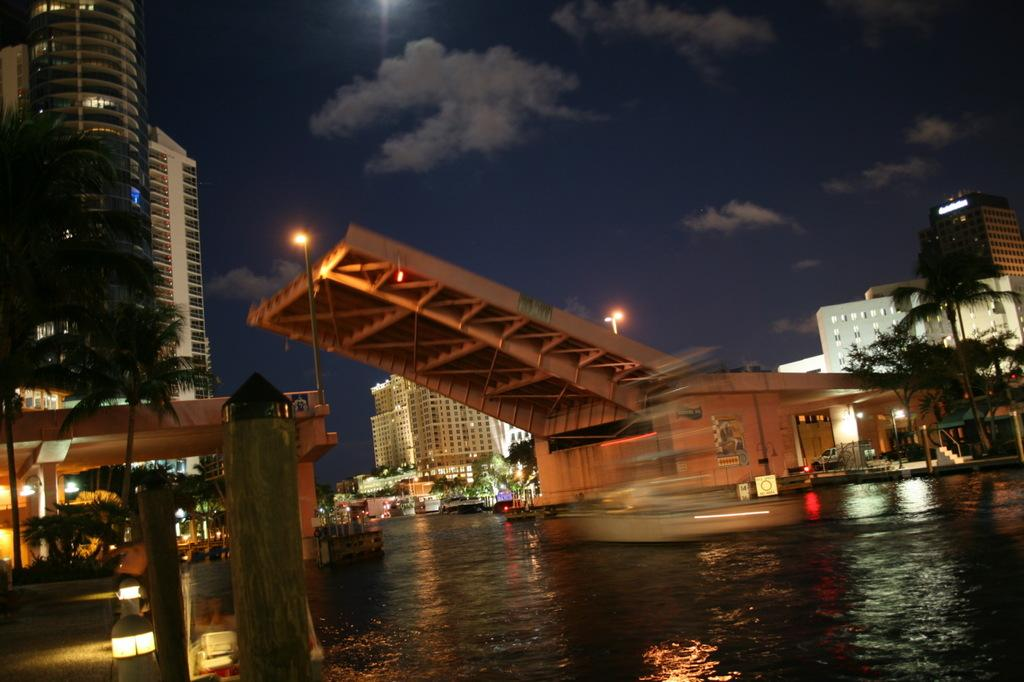What is present in the image that represents a body of water? There is water in the image. What structure can be seen crossing over the water? There is a bridge in the image. What type of man-made structures are visible in the image? There are buildings in the image. What type of vegetation can be seen in the image? There are trees in the image. What type of illumination is present in the image? There are lights in the image. What can be observed about the sky in the background of the image? The sky in the background is dark. What nation is represented by the flags in the image? There are no flags present in the image, so it is not possible to determine which nation is represented. How many men are visible in the image? There are no men visible in the image; the focus is on the water, bridge, buildings, trees, lights, and sky. 